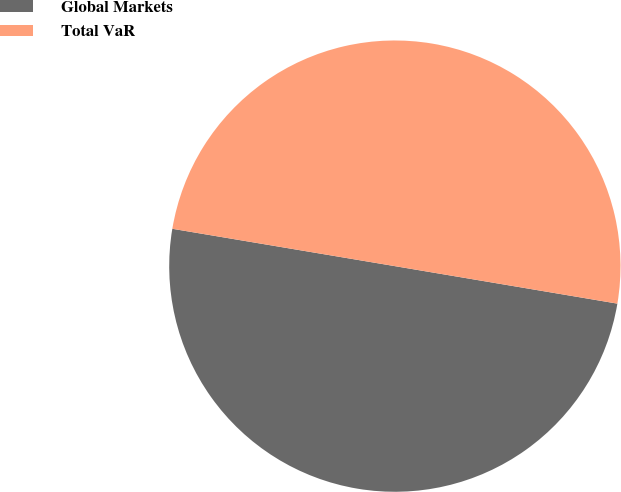Convert chart. <chart><loc_0><loc_0><loc_500><loc_500><pie_chart><fcel>Global Markets<fcel>Total VaR<nl><fcel>49.99%<fcel>50.01%<nl></chart> 